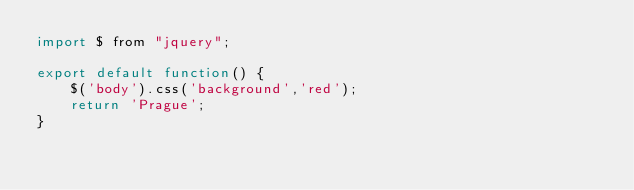<code> <loc_0><loc_0><loc_500><loc_500><_JavaScript_>import $ from "jquery";

export default function() {
    $('body').css('background','red');
    return 'Prague';
}</code> 